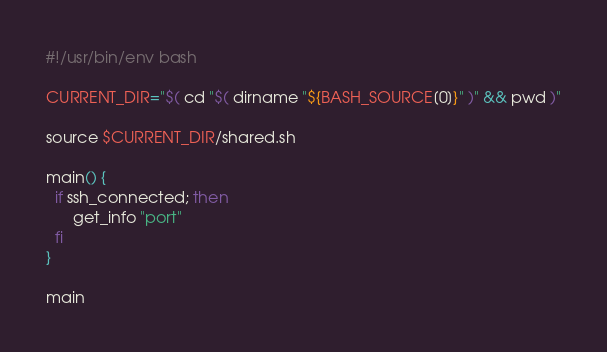Convert code to text. <code><loc_0><loc_0><loc_500><loc_500><_Bash_>#!/usr/bin/env bash

CURRENT_DIR="$( cd "$( dirname "${BASH_SOURCE[0]}" )" && pwd )"

source $CURRENT_DIR/shared.sh

main() {
  if ssh_connected; then
      get_info "port"
  fi
}

main
</code> 